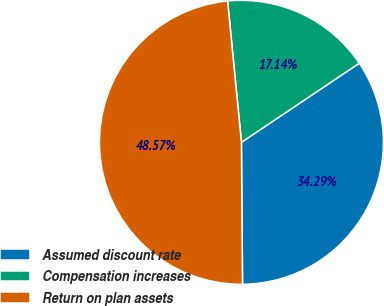<chart> <loc_0><loc_0><loc_500><loc_500><pie_chart><fcel>Assumed discount rate<fcel>Compensation increases<fcel>Return on plan assets<nl><fcel>34.29%<fcel>17.14%<fcel>48.57%<nl></chart> 